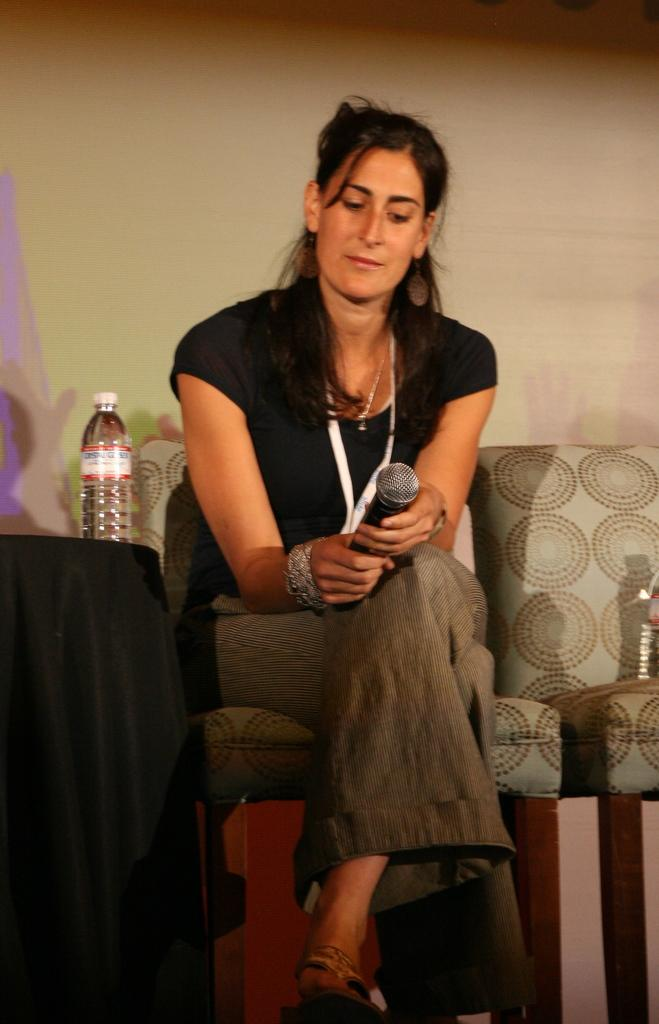Who is the main subject in the image? There is a woman in the image. What is the woman doing in the image? The woman is sitting on a chair and holding a microphone. What can be seen in the background of the image? There is a wall in the background of the image. Are there any other objects visible in the image? Yes, there is a bottle in the image. Can you tell me how many passengers are in the image? There are no passengers present in the image; it features a woman sitting on a chair and holding a microphone. What type of swimwear is the woman wearing in the image? There is no swimwear visible in the image; the woman is wearing regular clothing. 